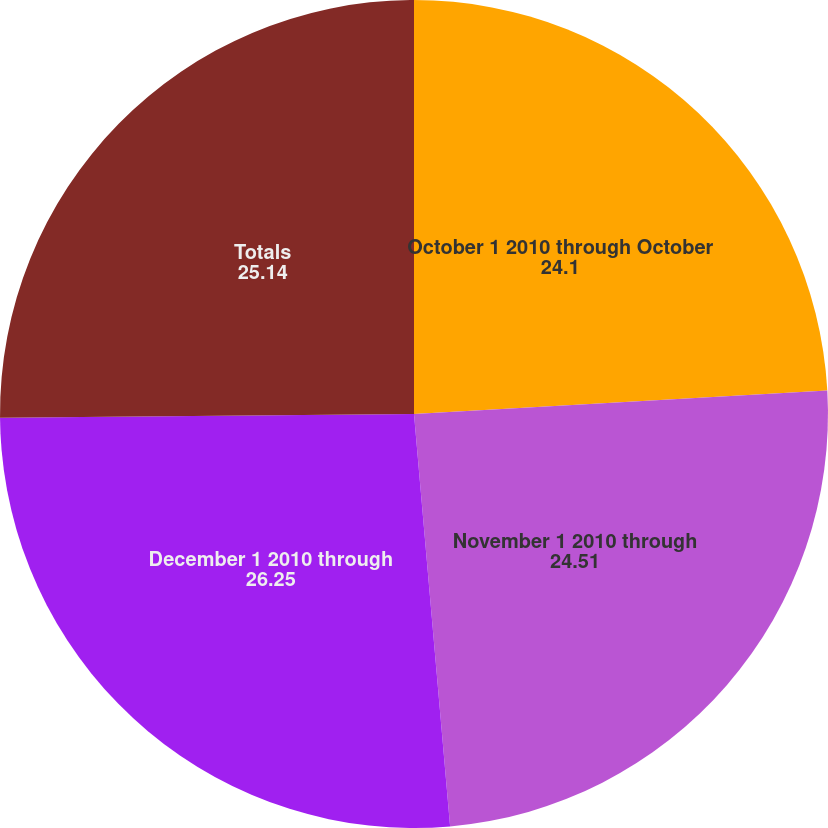Convert chart. <chart><loc_0><loc_0><loc_500><loc_500><pie_chart><fcel>October 1 2010 through October<fcel>November 1 2010 through<fcel>December 1 2010 through<fcel>Totals<nl><fcel>24.1%<fcel>24.51%<fcel>26.25%<fcel>25.14%<nl></chart> 